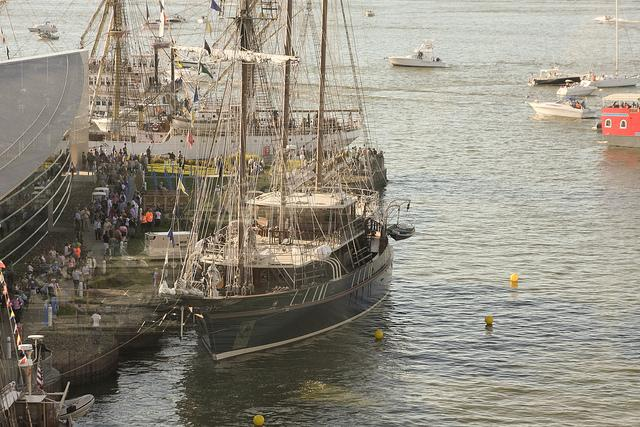What century of advancement might this boat belong to? 18th 